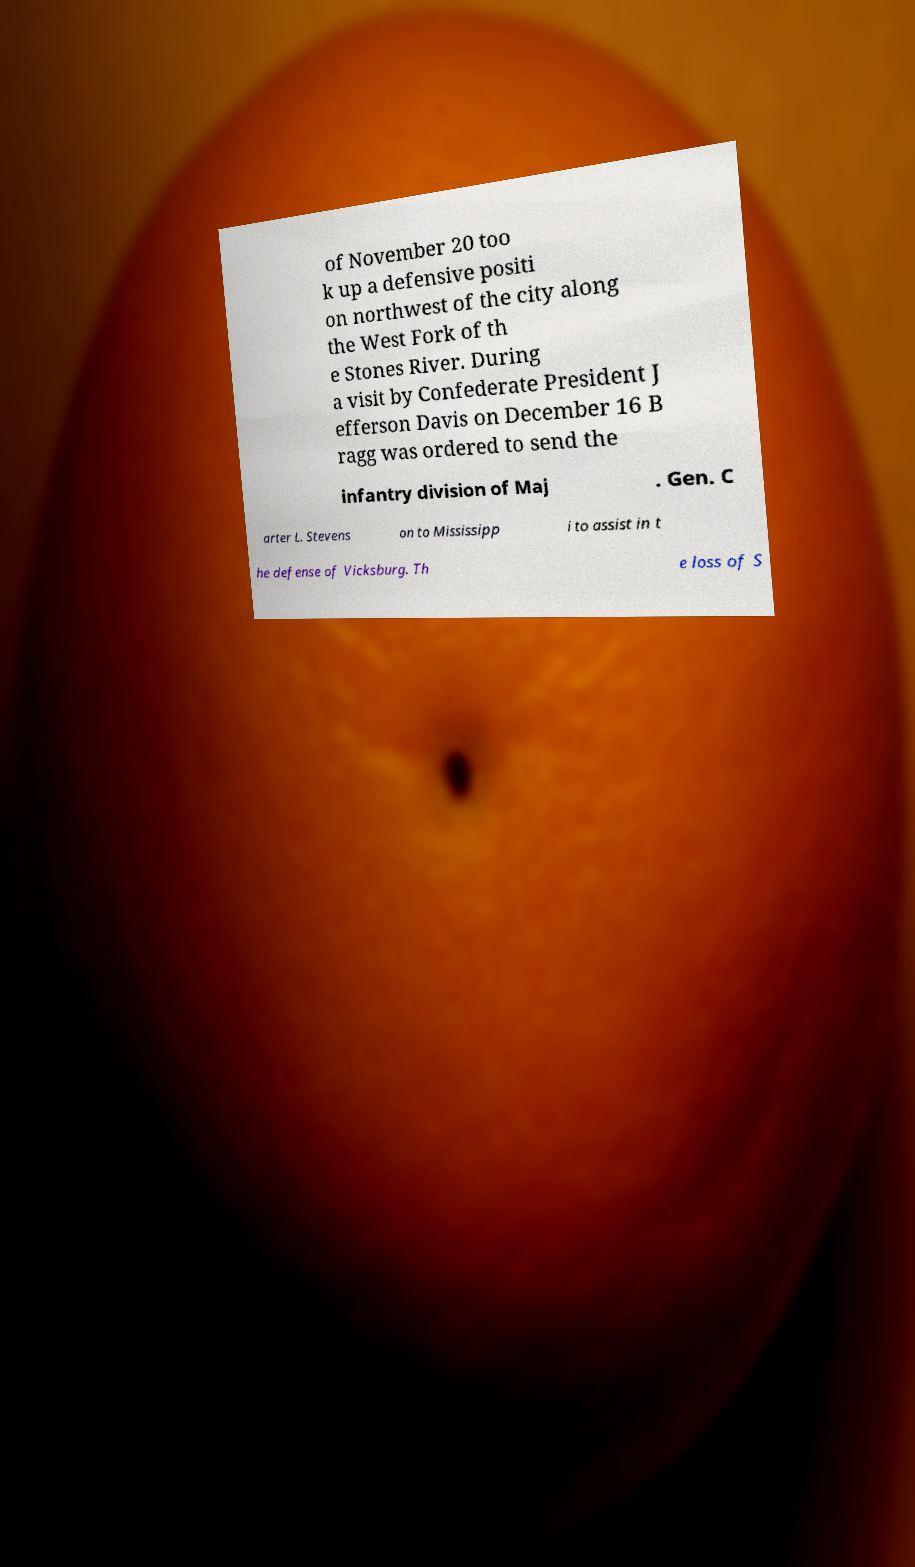Can you accurately transcribe the text from the provided image for me? of November 20 too k up a defensive positi on northwest of the city along the West Fork of th e Stones River. During a visit by Confederate President J efferson Davis on December 16 B ragg was ordered to send the infantry division of Maj . Gen. C arter L. Stevens on to Mississipp i to assist in t he defense of Vicksburg. Th e loss of S 